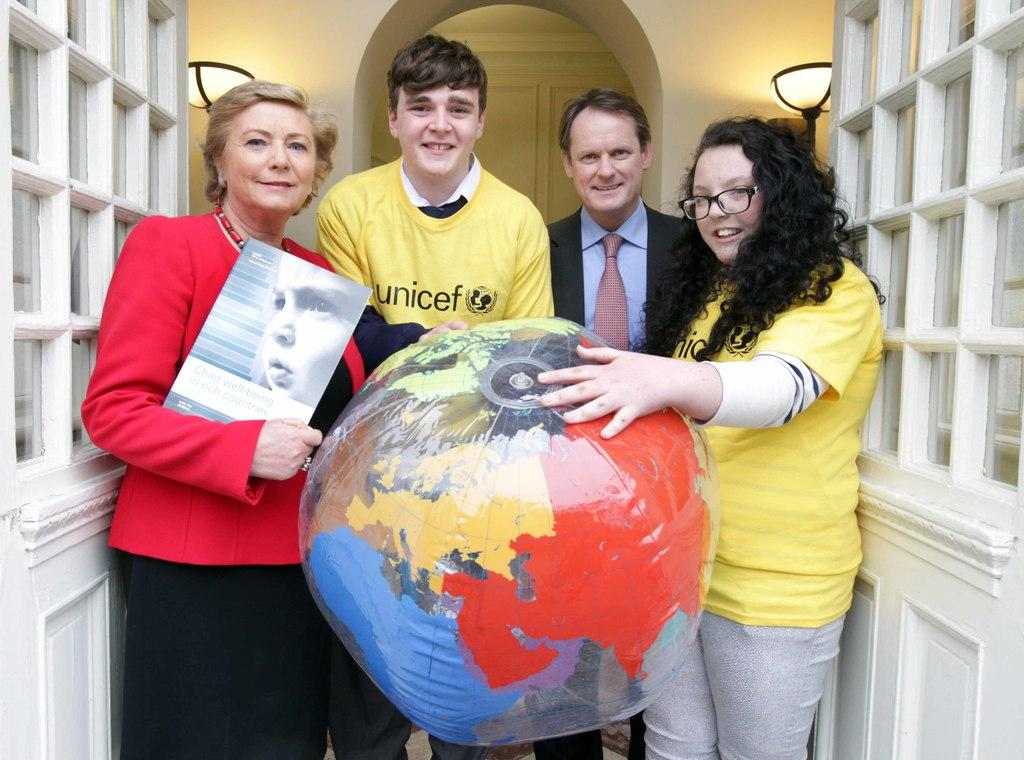What is the main object in the image? There is a door in the image. What are the people in the image doing? The people are standing and holding balloons. Can you describe the woman in the image? The woman is holding a poster. What can be seen in the background of the image? There is a wall and lights in the background of the image. What type of star can be seen in the image? There is no star present in the image. What class is the woman teaching in the image? There is no indication of a class or teaching in the image. 